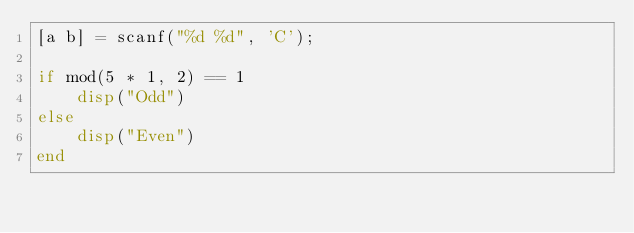Convert code to text. <code><loc_0><loc_0><loc_500><loc_500><_Octave_>[a b] = scanf("%d %d", 'C');

if mod(5 * 1, 2) == 1
    disp("Odd")
else
    disp("Even")
end</code> 